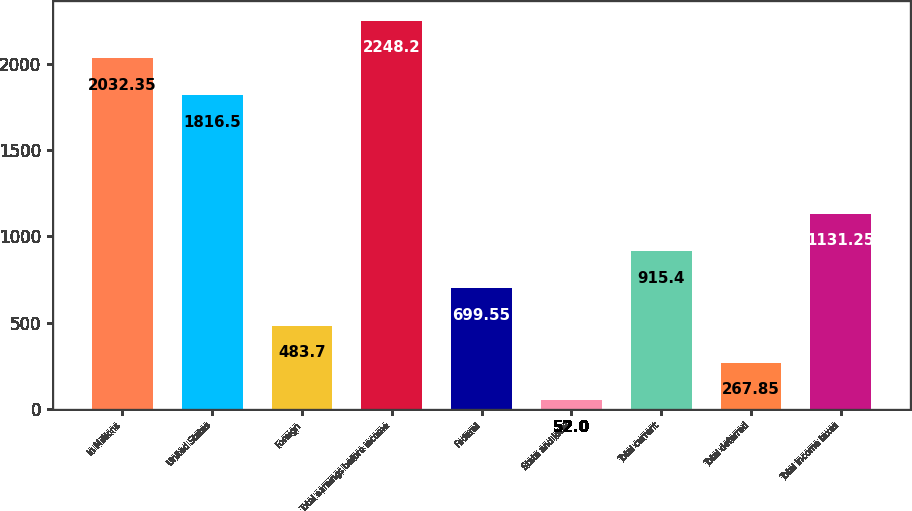Convert chart to OTSL. <chart><loc_0><loc_0><loc_500><loc_500><bar_chart><fcel>In Millions<fcel>United States<fcel>Foreign<fcel>Total earnings before income<fcel>Federal<fcel>State and local<fcel>Total current<fcel>Total deferred<fcel>Total income taxes<nl><fcel>2032.35<fcel>1816.5<fcel>483.7<fcel>2248.2<fcel>699.55<fcel>52<fcel>915.4<fcel>267.85<fcel>1131.25<nl></chart> 